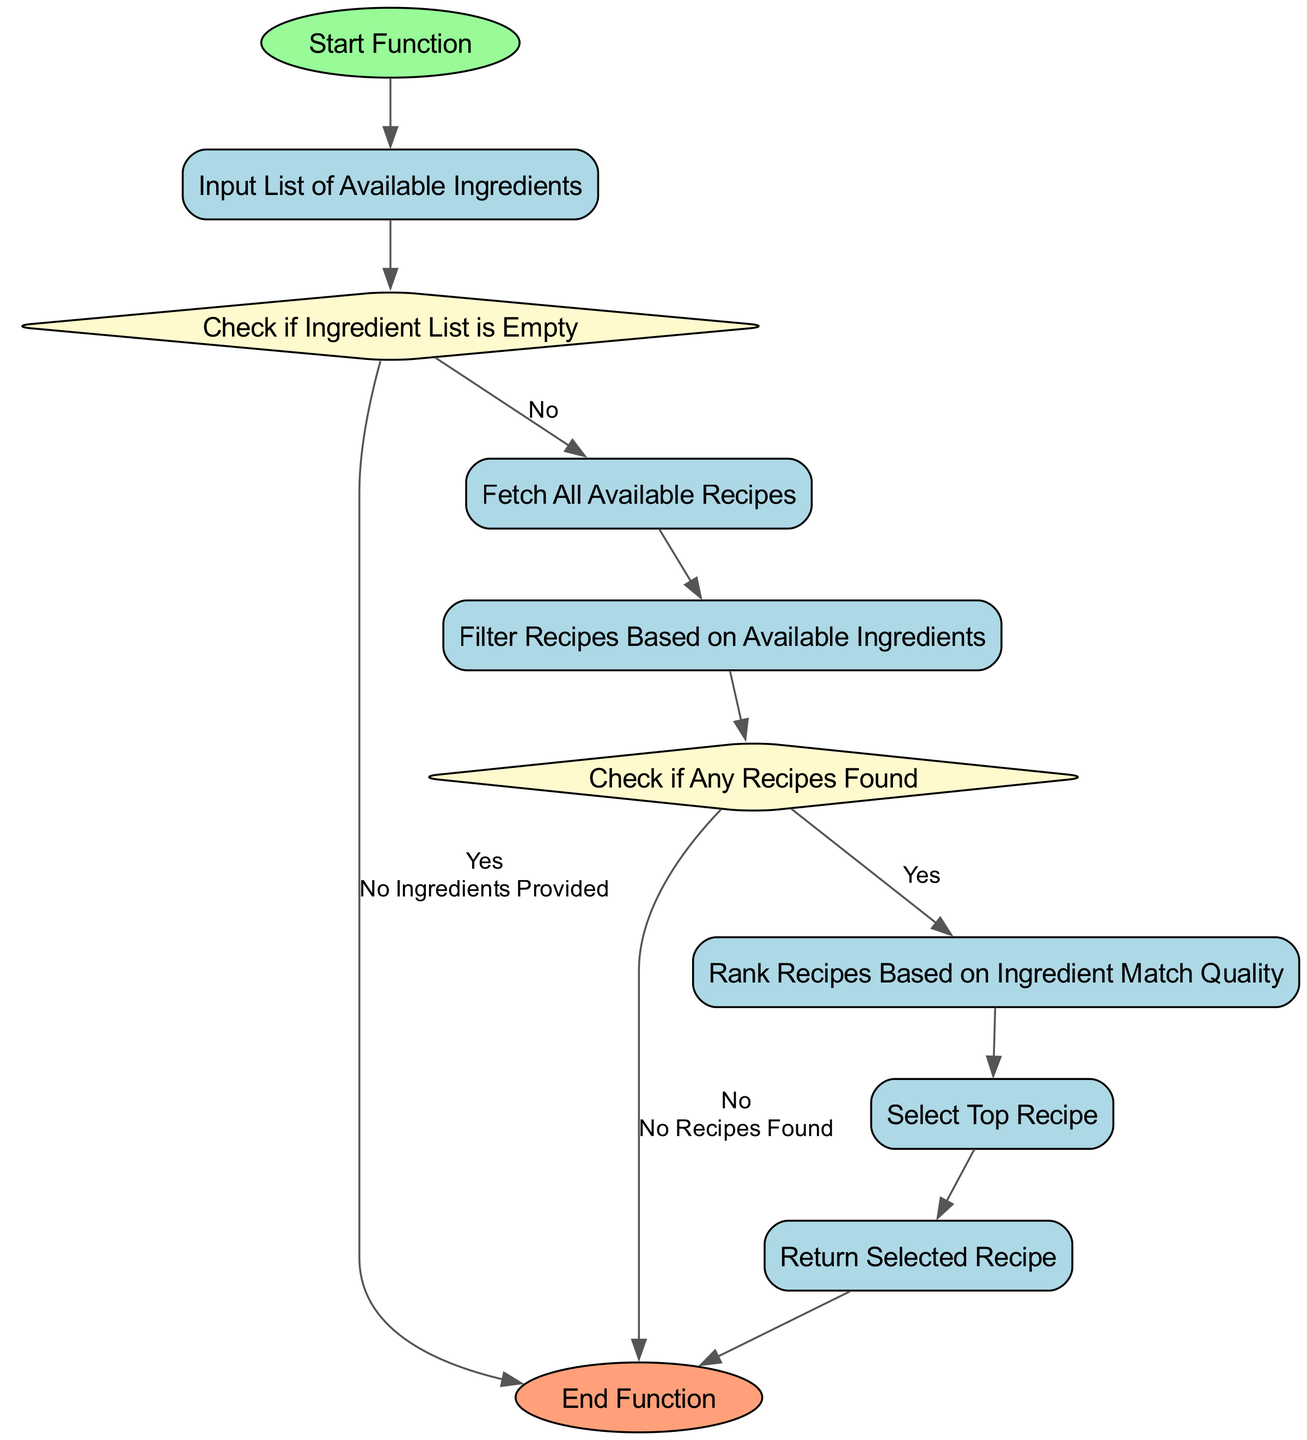What is the first step in the flowchart? The first step is represented by the "Start Function" node, which indicates the beginning of the process.
Answer: Start Function How many decision nodes are present in the diagram? There are two decision nodes in the diagram: "Check if Ingredient List is Empty" and "Check if Any Recipes Found."
Answer: 2 What happens if the ingredient list is empty? If the ingredient list is empty, the flow will end and return the message 'No Ingredients Provided.'
Answer: End What does the diagram do after filtering recipes based on available ingredients? After filtering recipes, the next step is to check if any recipes were found using the decision node "Check if Any Recipes Found."
Answer: Check if Any Recipes Found Which node follows after ranking recipes? The node that follows after ranking recipes is "Select Top Recipe," which indicates the choice of the best recipe.
Answer: Select Top Recipe What result occurs if no recipes are found after filtering? If no recipes are found, the flow will end and return the message 'No Recipes Found.'
Answer: End How many total nodes are present in the diagram? The diagram contains a total of seven nodes in addition to the start and end nodes, making it a total of nine nodes overall.
Answer: 9 What will the function return after selecting the top recipe? After selecting the top recipe, the function will return the selected recipe to the user.
Answer: Return Selected Recipe If the input ingredient list contains items, which step comes after fetching recipes? If ingredients are provided, after fetching recipes, the next step is to filter recipes based on the available ingredients.
Answer: Filter Recipes Based on Available Ingredients 